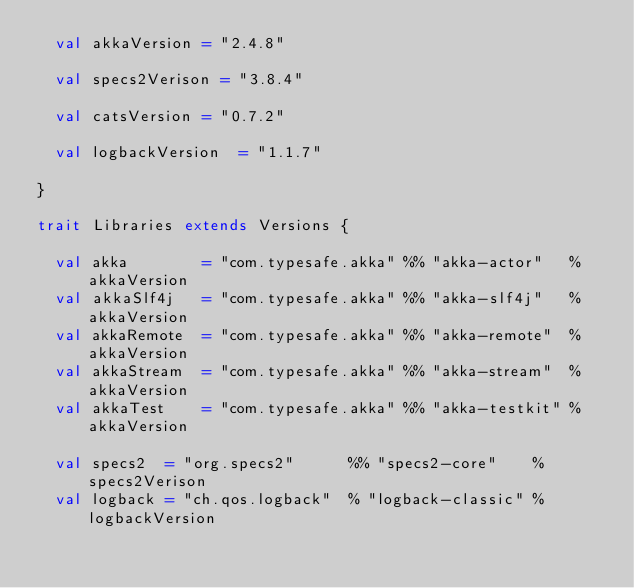Convert code to text. <code><loc_0><loc_0><loc_500><loc_500><_Scala_>  val akkaVersion = "2.4.8"

  val specs2Verison = "3.8.4"

  val catsVersion = "0.7.2"

  val logbackVersion  = "1.1.7"

}

trait Libraries extends Versions {

  val akka        = "com.typesafe.akka" %% "akka-actor"   % akkaVersion
  val akkaSlf4j   = "com.typesafe.akka" %% "akka-slf4j"   % akkaVersion
  val akkaRemote  = "com.typesafe.akka" %% "akka-remote"  % akkaVersion
  val akkaStream  = "com.typesafe.akka" %% "akka-stream"  % akkaVersion
  val akkaTest    = "com.typesafe.akka" %% "akka-testkit" % akkaVersion

  val specs2  = "org.specs2"      %% "specs2-core"    % specs2Verison
  val logback = "ch.qos.logback"  % "logback-classic" % logbackVersion
</code> 